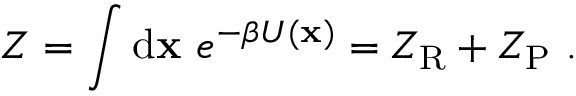<formula> <loc_0><loc_0><loc_500><loc_500>Z = \int d x \ e ^ { - \beta U ( x ) } = Z _ { R } + Z _ { P } \ .</formula> 